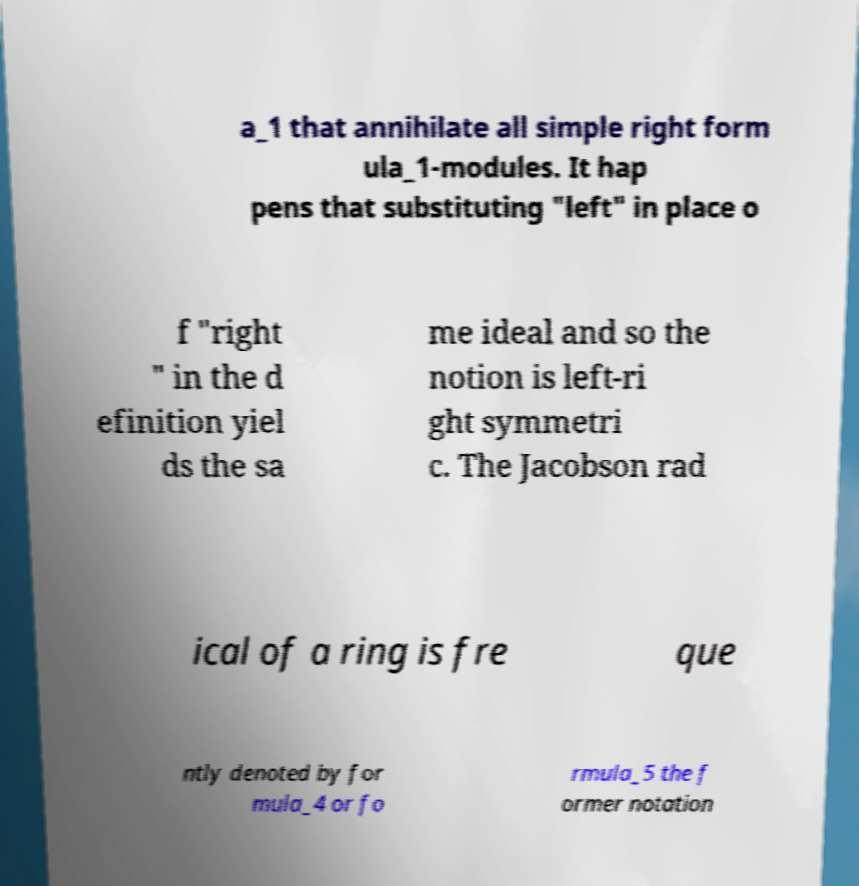I need the written content from this picture converted into text. Can you do that? a_1 that annihilate all simple right form ula_1-modules. It hap pens that substituting "left" in place o f "right " in the d efinition yiel ds the sa me ideal and so the notion is left-ri ght symmetri c. The Jacobson rad ical of a ring is fre que ntly denoted by for mula_4 or fo rmula_5 the f ormer notation 